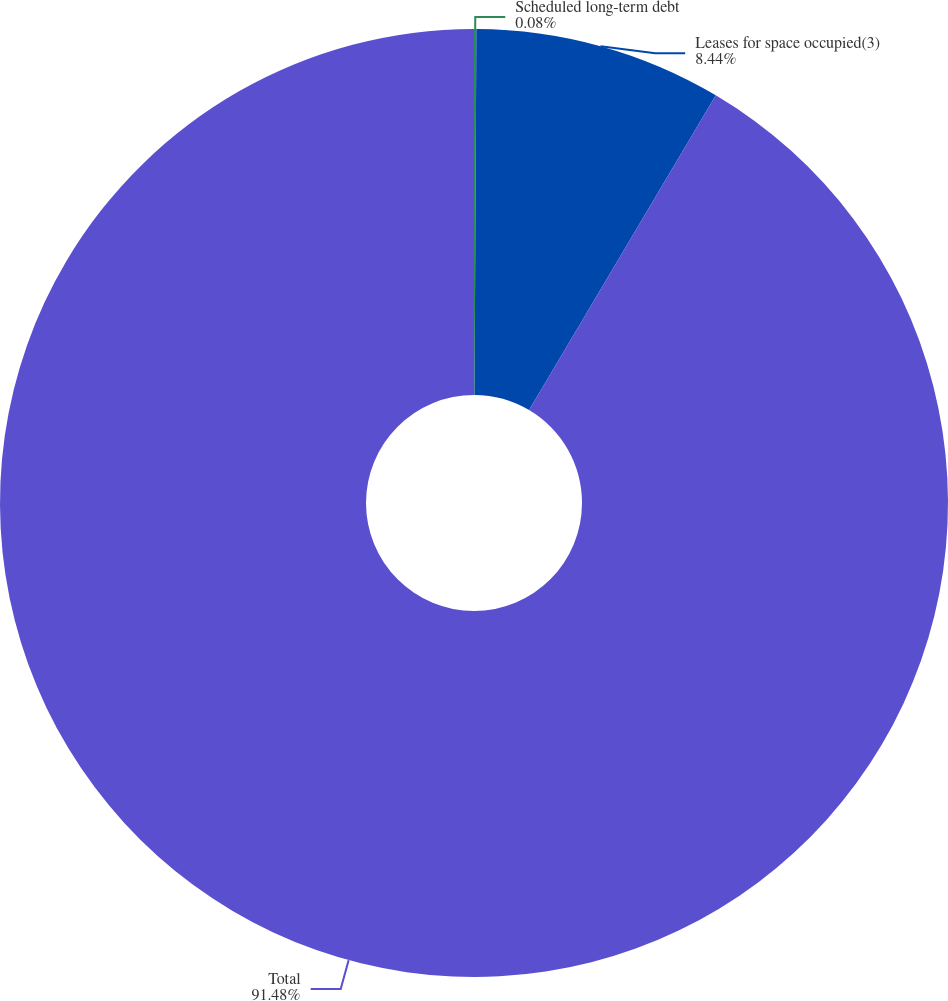Convert chart. <chart><loc_0><loc_0><loc_500><loc_500><pie_chart><fcel>Scheduled long-term debt<fcel>Leases for space occupied(3)<fcel>Total<nl><fcel>0.08%<fcel>8.44%<fcel>91.48%<nl></chart> 